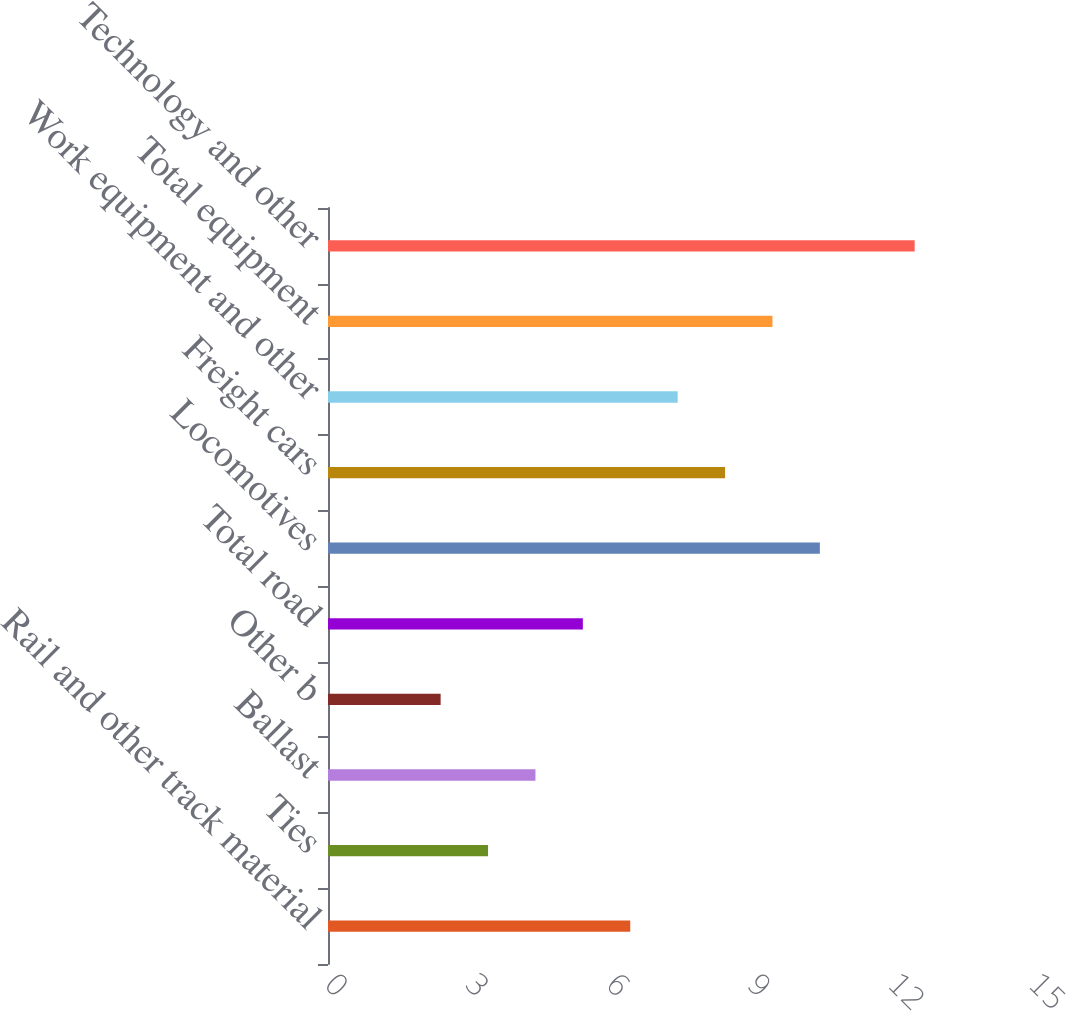Convert chart to OTSL. <chart><loc_0><loc_0><loc_500><loc_500><bar_chart><fcel>Rail and other track material<fcel>Ties<fcel>Ballast<fcel>Other b<fcel>Total road<fcel>Locomotives<fcel>Freight cars<fcel>Work equipment and other<fcel>Total equipment<fcel>Technology and other<nl><fcel>6.44<fcel>3.41<fcel>4.42<fcel>2.4<fcel>5.43<fcel>10.48<fcel>8.46<fcel>7.45<fcel>9.47<fcel>12.5<nl></chart> 